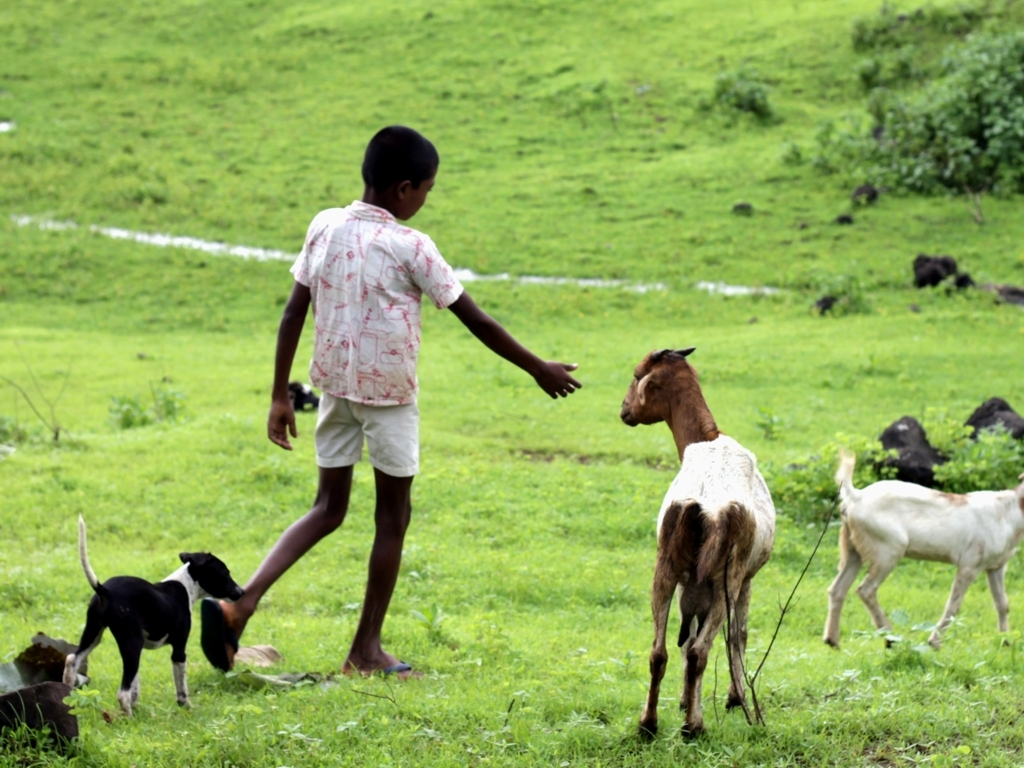Do the colors in the image look vibrant and vivid? Absolutely, the image is teeming with vibrancy and vividness. The green hues of the vegetation are bright and lively, providing a fresh backdrop that contrasts beautifully with the earthy tones of the animals and the child's attire. The natural daylight enhances the overall vibrancy, giving the scene an energetic and dynamic feel. 